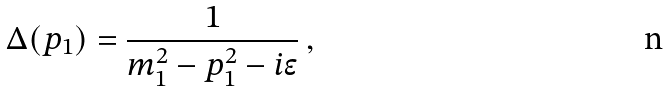<formula> <loc_0><loc_0><loc_500><loc_500>\Delta ( p _ { 1 } ) = \frac { 1 } { m _ { 1 } ^ { 2 } - p _ { 1 } ^ { 2 } - i \epsilon } \, ,</formula> 